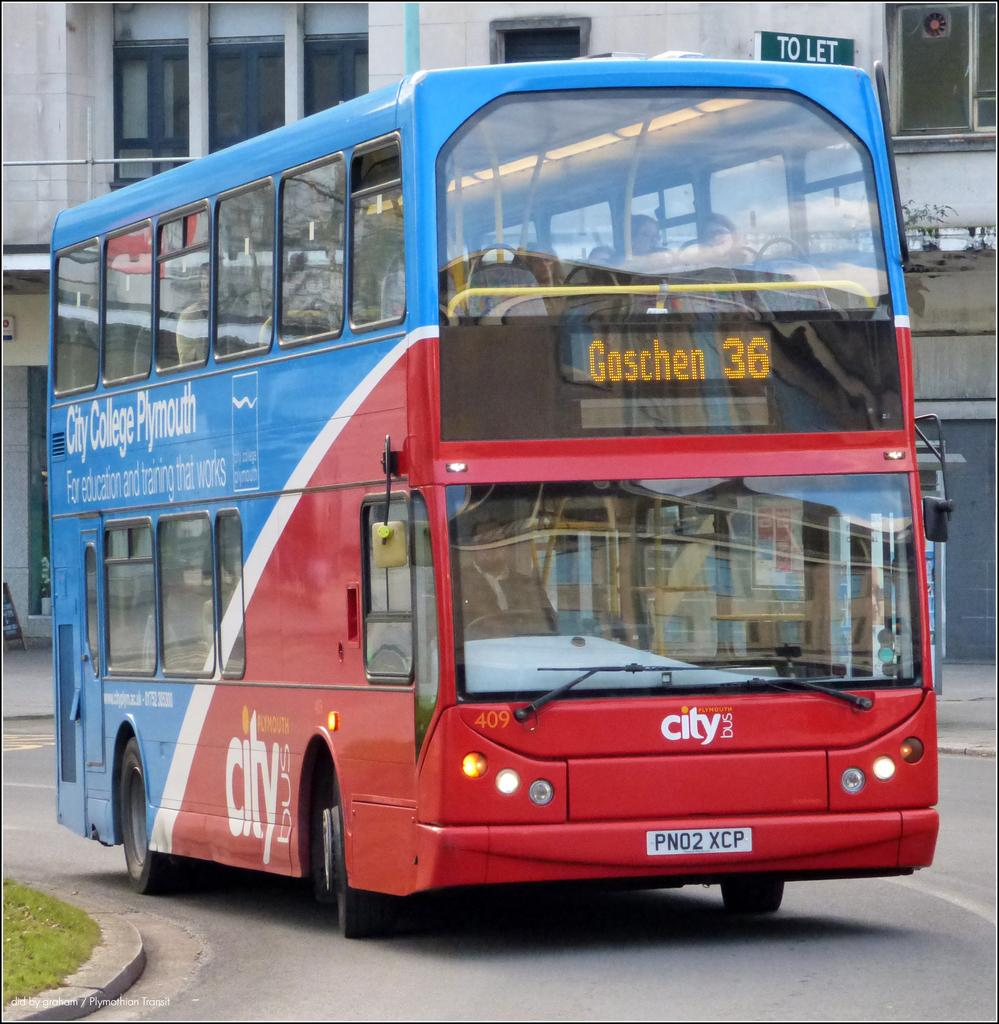Provide a one-sentence caption for the provided image. A double decker bus that is going to Goschen. 